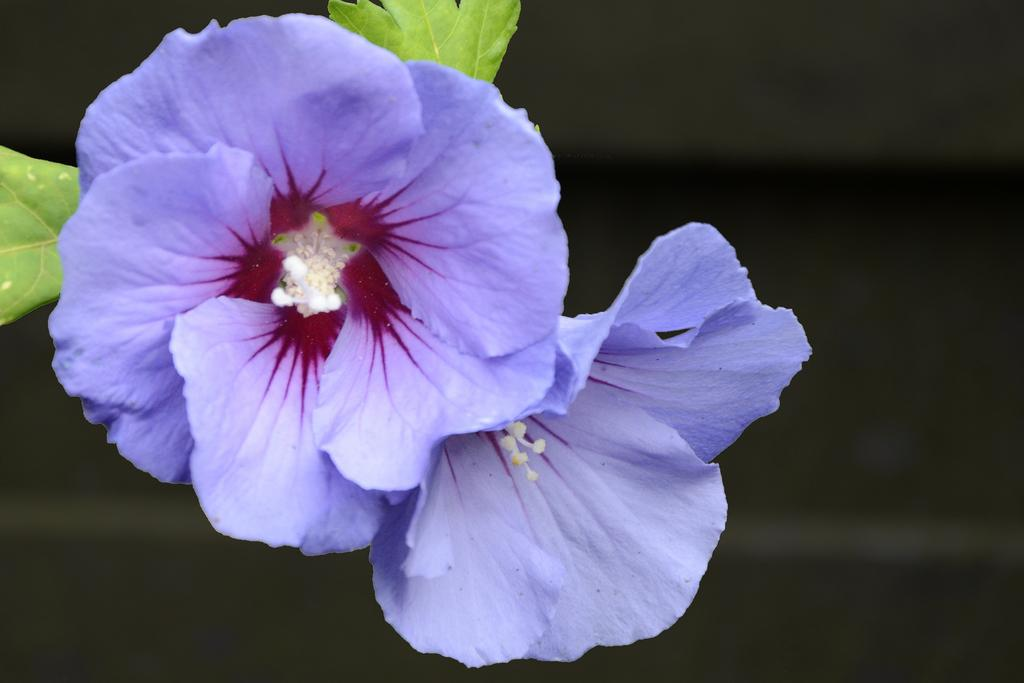What type of flowers can be seen in the image? There are light purple color flowers in the image. How many leaves are visible in the image? There are two leaves in the image. Can you describe the background of the image? The background of the image is blurry. Can you tell me how many bones are visible in the image? There are no bones present in the image; it features flowers and leaves. Is there a lake visible in the image? There is no lake present in the image; it features flowers and leaves. 